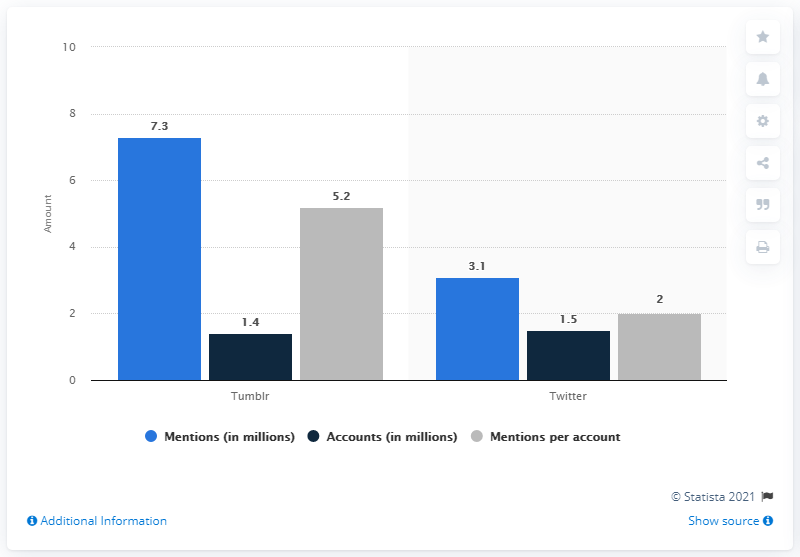Give some essential details in this illustration. The total number of mentions on both Twitter and Tumblr is 10,4... The total number of mentions on Twitter is 3.1. 